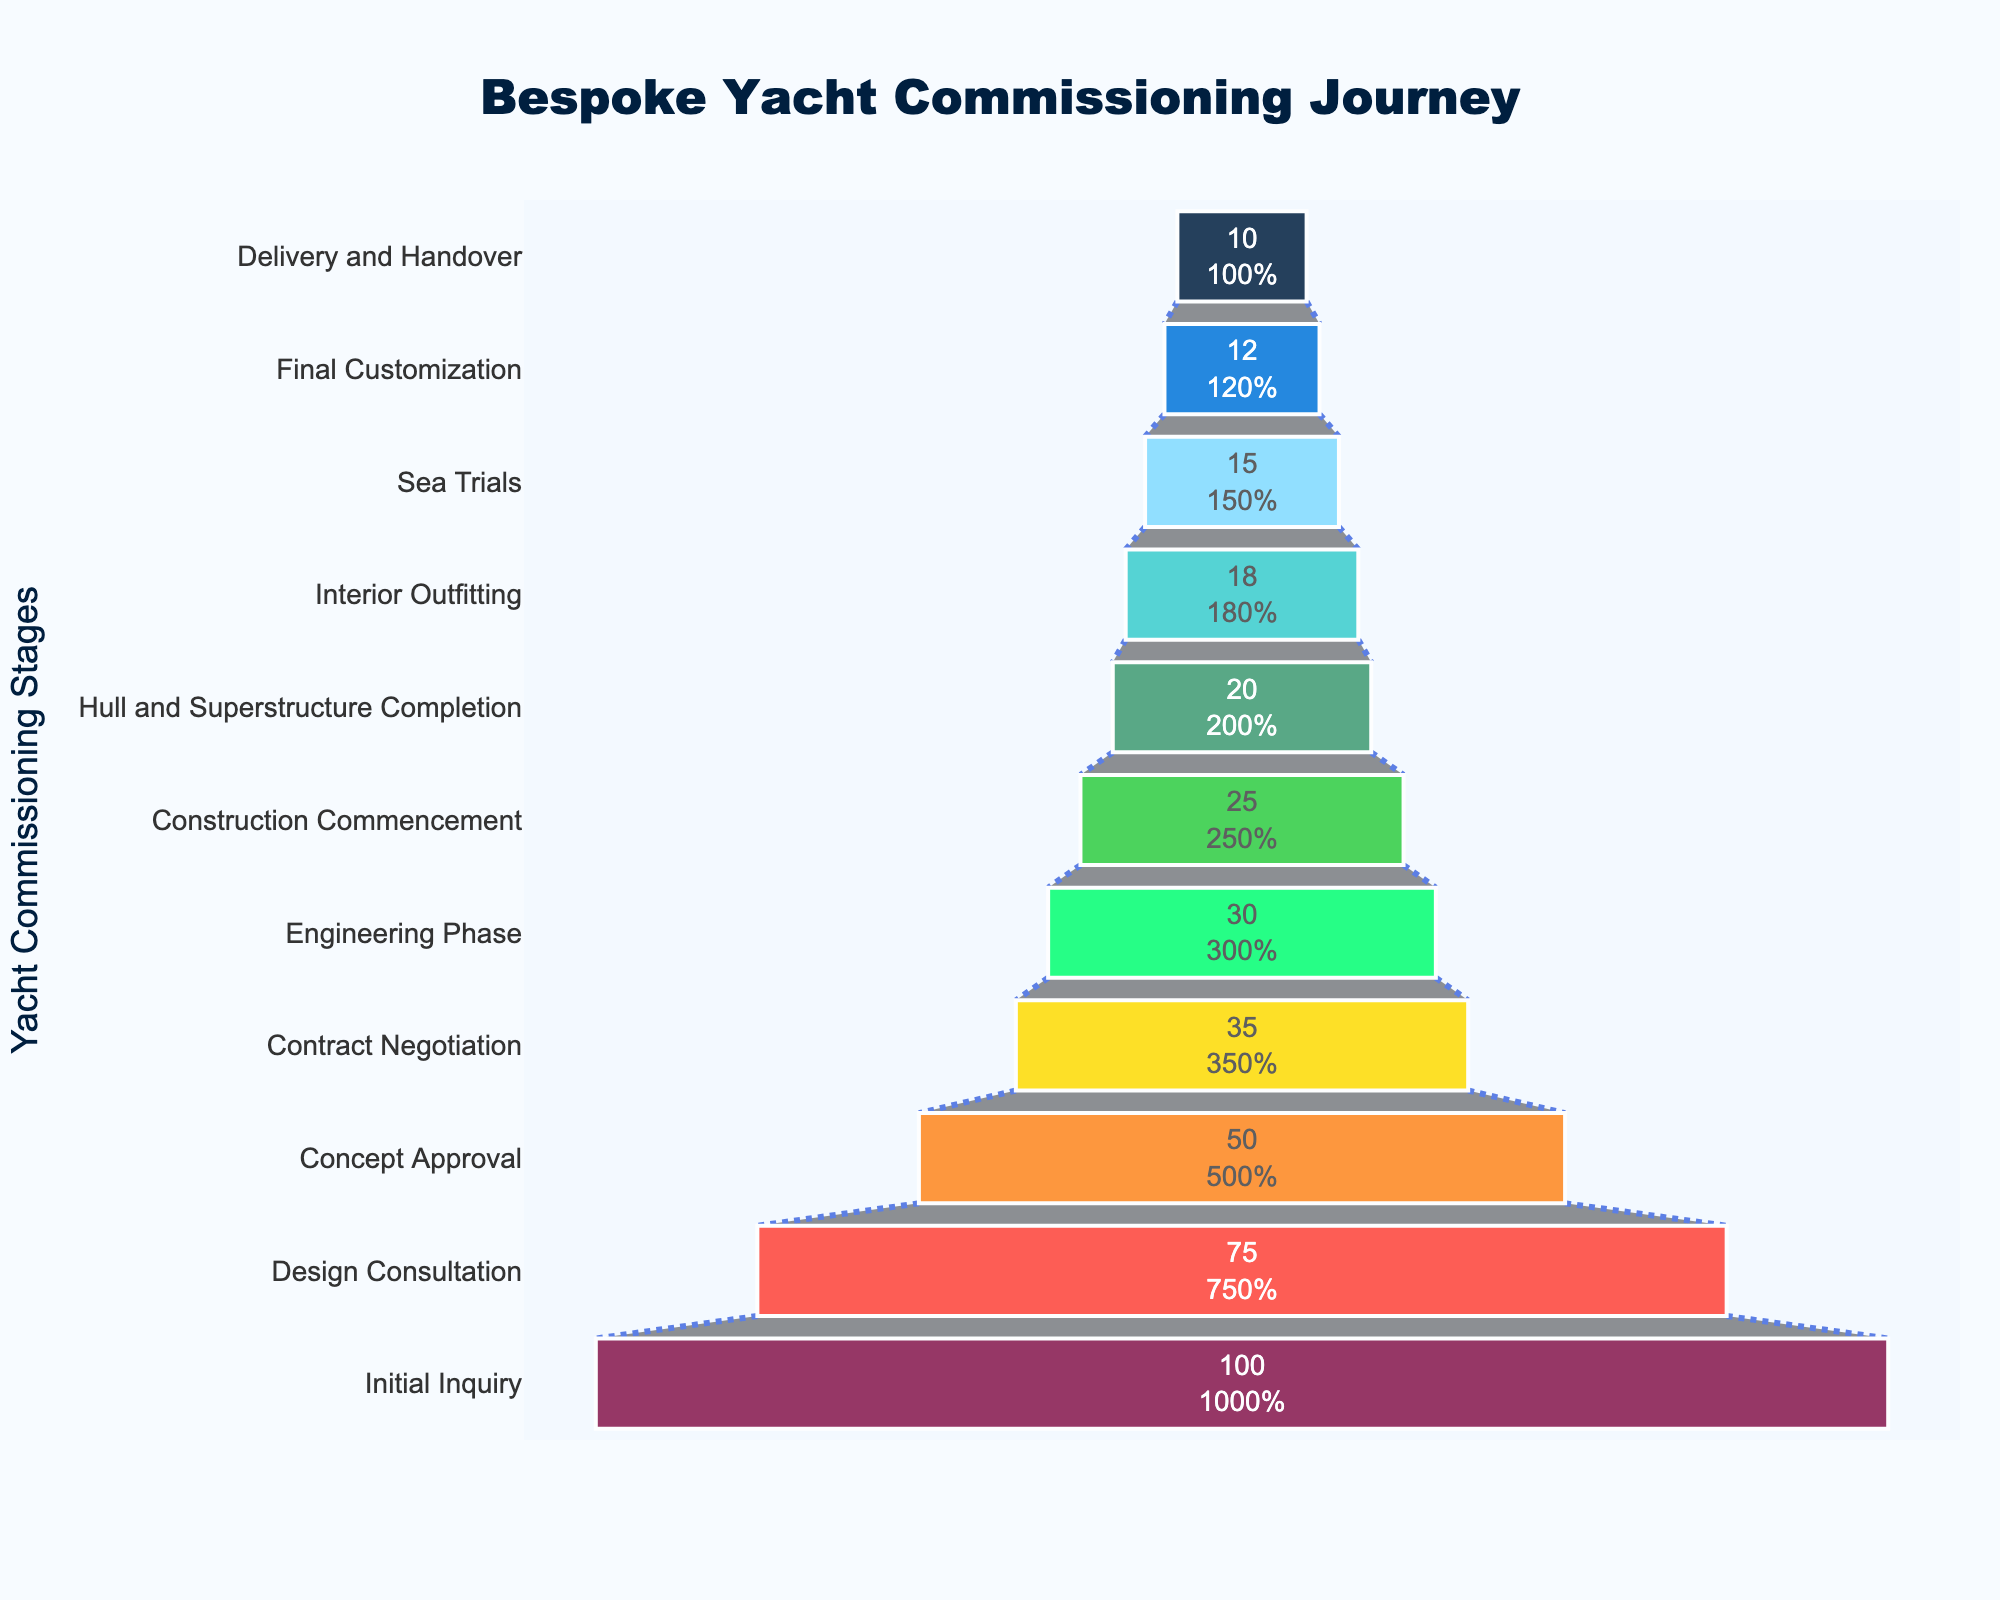What is the title of the chart? The title is displayed at the top center of the chart, indicating the subject of the visualization.
Answer: Bespoke Yacht Commissioning Journey How many clients reach the Design Consultation stage? The number of clients at each stage is represented by the horizontal bars. The bar labeled 'Design Consultation' shows the number of clients that progress to this stage.
Answer: 75 Which stage has the largest drop in client numbers compared to the previous stage? Comparing the differences in client numbers between consecutive stages, the largest drop can be identified. The biggest difference is between 'Initial Inquiry' and 'Design Consultation' (100 - 75).
Answer: Initial Inquiry to Design Consultation What percentage of clients make it to the Delivery and Handover stage? The percentage is shown inside the corresponding funnel segment. It is derived by taking the number of clients at the final stage and dividing it by the number at the initial stage, multiplying by 100.
Answer: 10% How many clients drop out between the Contract Negotiation stage and the Engineering Phase stage? To find the drop-out number, subtract the number of clients in the Engineering Phase stage from those in the Contract Negotiation stage (35 - 30).
Answer: 5 At which stage do clients drop below 50% of the initial inquiry number? Identifying the stage where the client number first falls below 50% of the initial number (100 clients in Initial Inquiry). This is below 50 clients, which happens at 'Concept Approval'.
Answer: Concept Approval What is the total number of clients lost from Initial Inquiry to Delivery and Handover? Subtract the number of clients in the final stage ('Delivery and Handover') from the initial stage ('Initial Inquiry') (100 - 10).
Answer: 90 Which stages retain clients closest to the previous stage's number? Look for the stages with the smallest differences between consecutive numbers. The smallest differences are between 'Engineering Phase' and 'Construction Commencement' (30 - 25) and between 'Interior Outfitting' and 'Sea Trials' (18 - 15).
Answer: Engineering Phase to Construction Commencement and Interior Outfitting to Sea Trials 